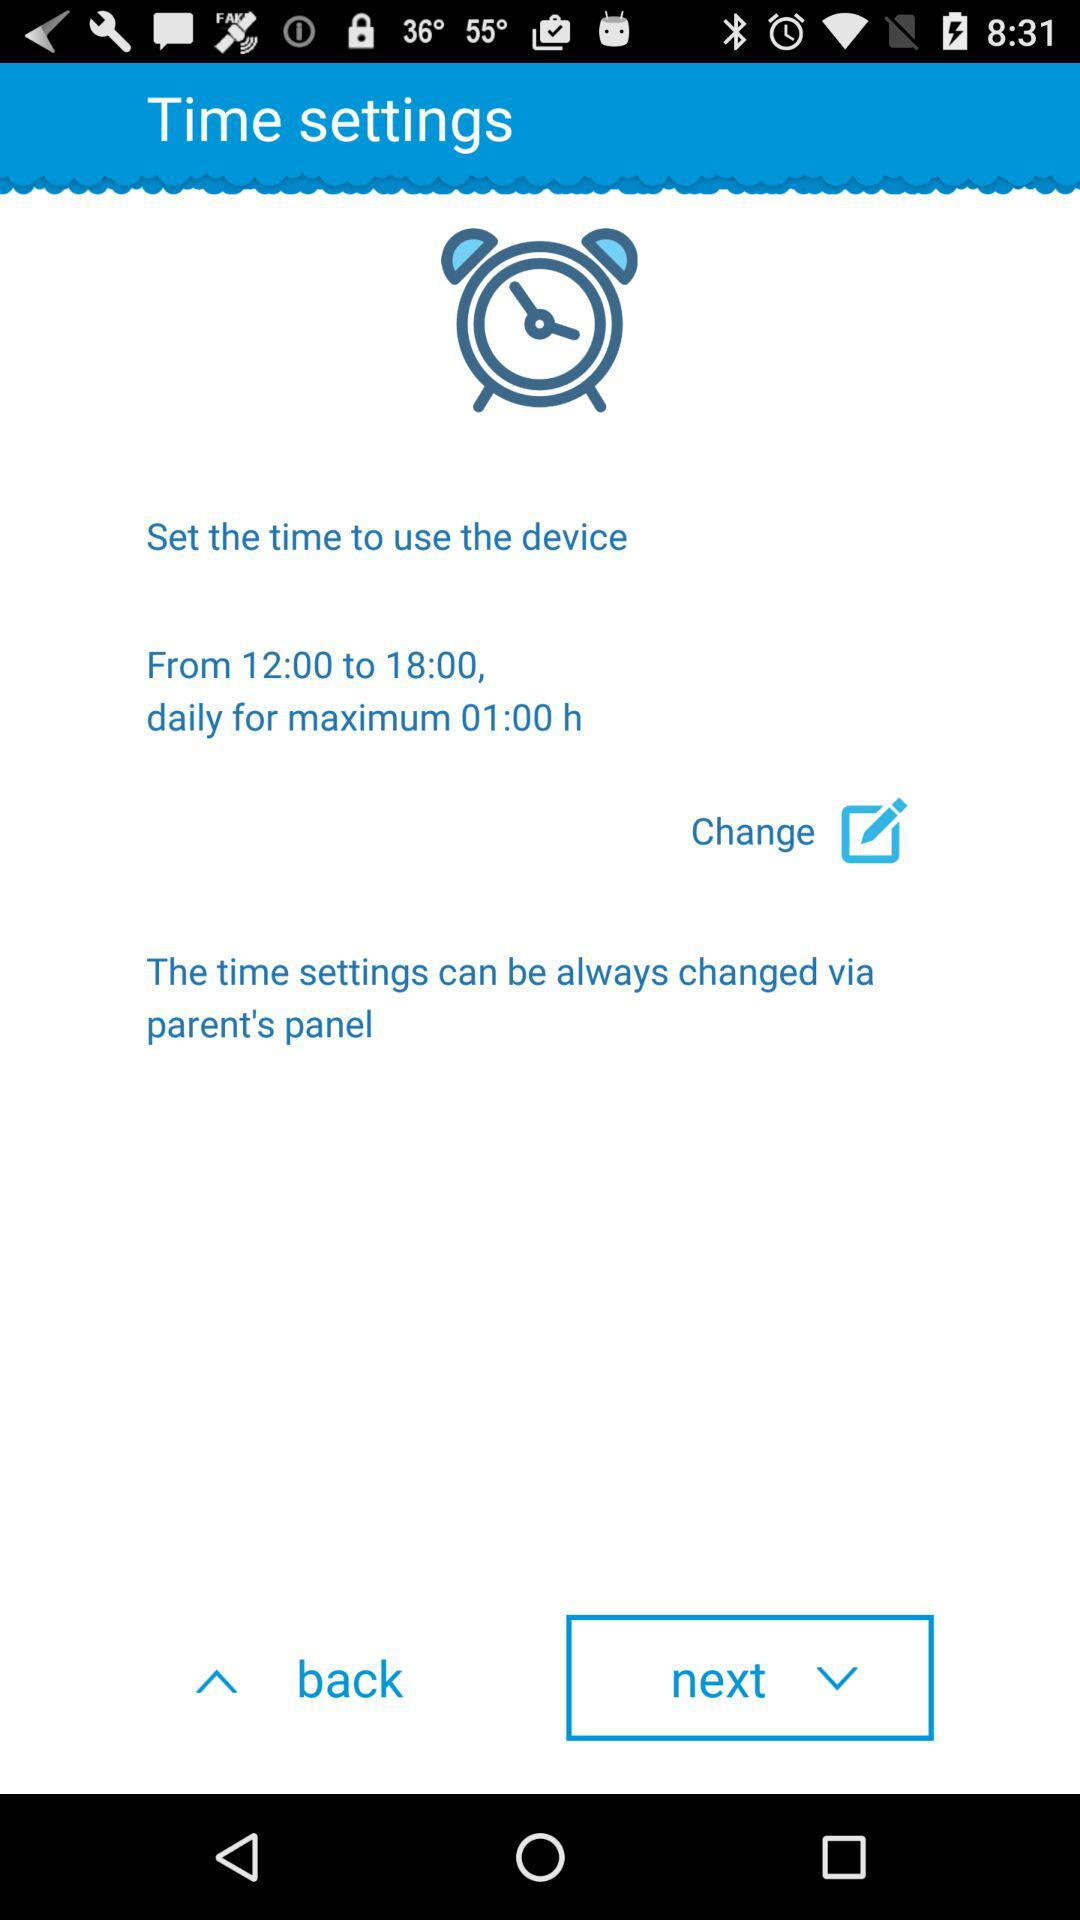What is the daily timing? The daily timing is from 12:00 to 18:00. 